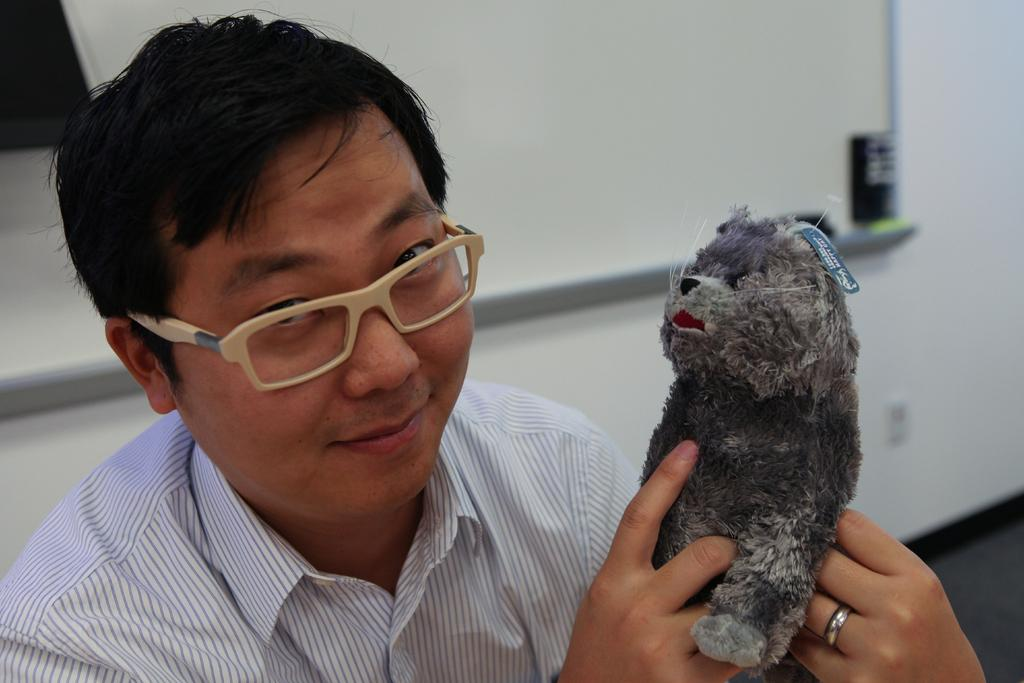What is in the background of the image? There is a whiteboard and a wall in the background of the image. What is the setting of the scene? The scene is set on a floor. Who is present in the image? There is a man in the image. What is the man wearing? The man is wearing spectacles. What is the man holding in his hands? The man is holding a doll in his hands. What type of wren can be seen copying the man's actions in the image? There is no wren present in the image, and the man's actions are not being copied by any other creature. 